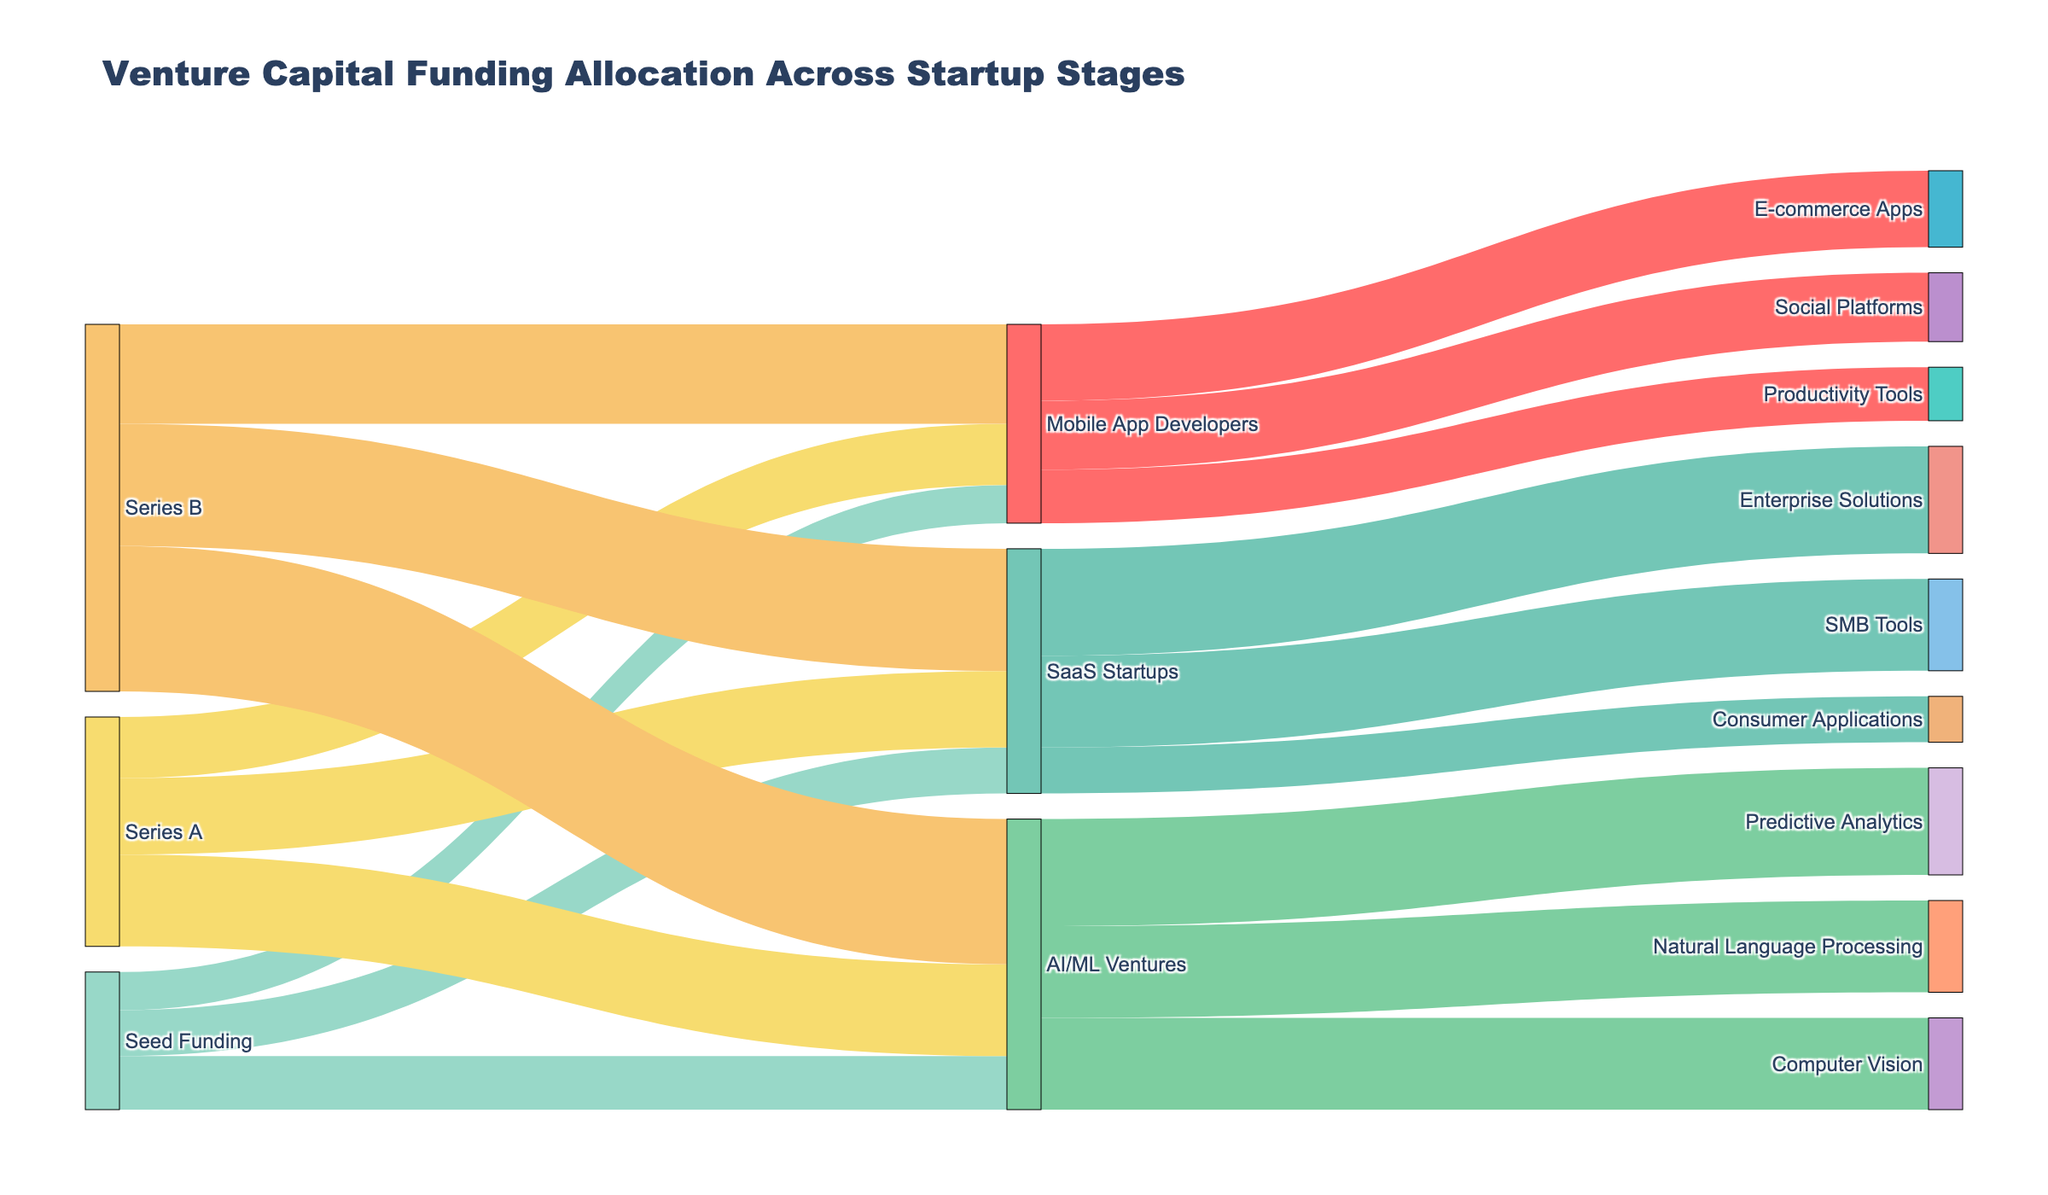which startup stage has the highest venture capital allocation? First, we need to identify the startup stages from the Sankey diagram, which are "Seed Funding", "Series A", and "Series B". Next, look at the values connected to each stage. "Series B" has 80+65+95 = 240, which is the highest.
Answer: Series B how much funding did AI/ML Ventures receive in total? Sum the values for AI/ML Ventures at different stages: 35 (Seed Funding) + 60 (Series A) + 95 (Series B) = 190.
Answer: 190 which two categories within AI/ML Ventures have equal allocations? Look at the allocation of "AI/ML Ventures" to its subcategories: Predictive Analytics (70), Computer Vision (60), and Natural Language Processing (60). The last two have equal allocations.
Answer: Computer Vision and Natural Language Processing compare the total funding received by Mobile App Developers and SaaS Startups across all stages. which one received more? Calculate the total for both categories: Mobile App Developers (25+40+65 = 130) and SaaS Startups (30+50+80 = 160). SaaS Startups received more.
Answer: SaaS Startups what is the funding allocation from SaaS Startups to Enterprise Solutions? Find the connection from "SaaS Startups" to "Enterprise Solutions" in the Sankey diagram. The value is 70.
Answer: 70 which funding stage contributes the most to SMB Tools among SaaS Startups? SMB Tools only receives funding from SaaS Startups, so check the total flow to "SMB Tools," which is 60. The only contributor is indirectly "Series B" with 80.
Answer: Series B what's the combined funding for Consumer Applications and Productivity Tools? Add the values: Consumer Applications (30) + Productivity Tools (35) = 65.
Answer: 65 compare the funding allocated to E-commerce Apps and Social Platforms within Mobile App Developers. which one received more? Check the values connected to these categories: E-commerce Apps (50) is higher than Social Platforms (45).
Answer: E-commerce Apps among AI/ML Ventures categories, which one got the highest funding? Check the values for all AI/ML Ventures categories: Predictive Analytics (70) is the highest.
Answer: Predictive Analytics how much venture capital moved from Series A to AI/ML Ventures? Find the value connected from Series A to AI/ML Ventures in the Sankey diagram, which is 60.
Answer: 60 